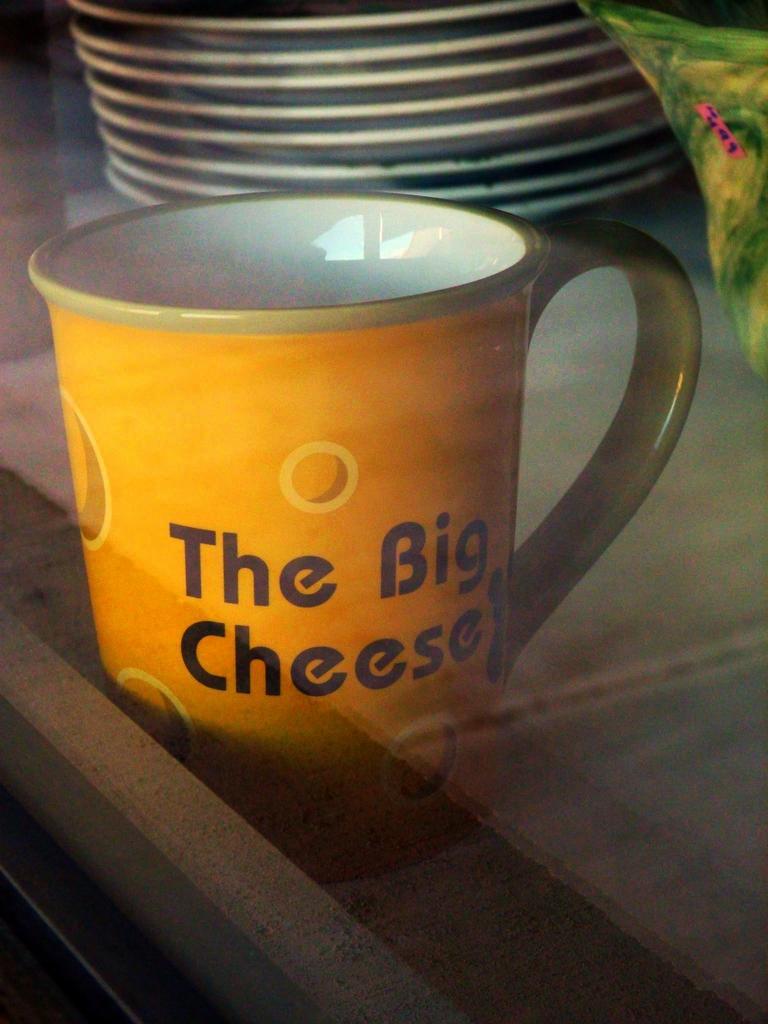Could you give a brief overview of what you see in this image? This is a zoomed in picture. In the center we can see the text on the mug placed on an object seems to be the table. In the background we can see the plates and some other object. 